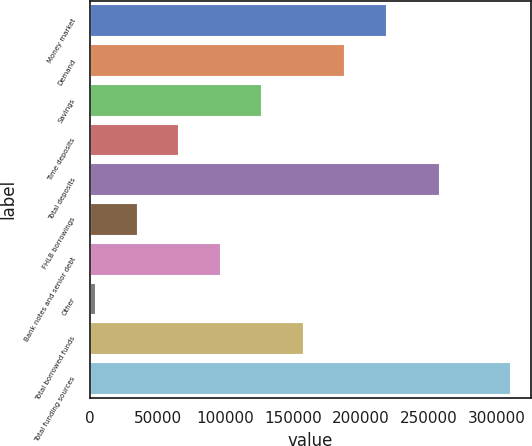<chart> <loc_0><loc_0><loc_500><loc_500><bar_chart><fcel>Money market<fcel>Demand<fcel>Savings<fcel>Time deposits<fcel>Total deposits<fcel>FHLB borrowings<fcel>Bank notes and senior debt<fcel>Other<fcel>Total borrowed funds<fcel>Total funding sources<nl><fcel>218162<fcel>187592<fcel>126454<fcel>65314.8<fcel>257164<fcel>34745.4<fcel>95884.2<fcel>4176<fcel>157023<fcel>309870<nl></chart> 